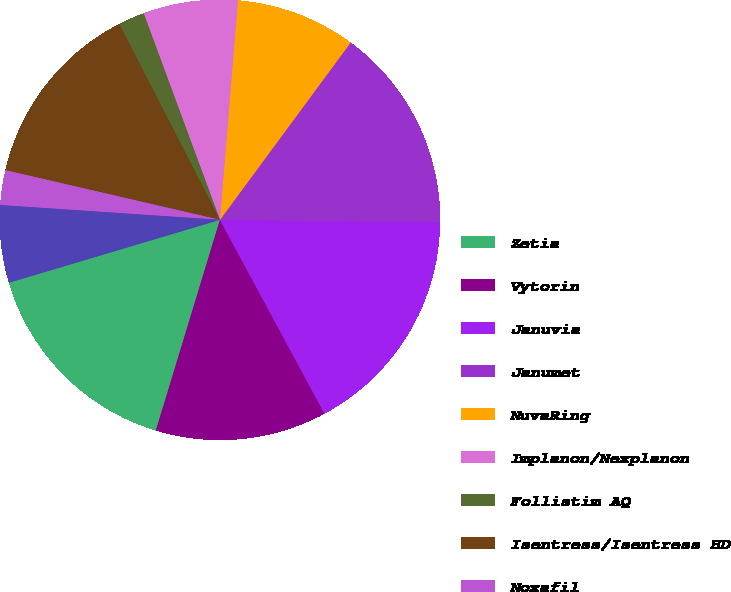Convert chart to OTSL. <chart><loc_0><loc_0><loc_500><loc_500><pie_chart><fcel>Zetia<fcel>Vytorin<fcel>Januvia<fcel>Janumet<fcel>NuvaRing<fcel>Implanon/Nexplanon<fcel>Follistim AQ<fcel>Isentress/Isentress HD<fcel>Noxafil<fcel>Invanz<nl><fcel>15.69%<fcel>12.57%<fcel>16.95%<fcel>15.07%<fcel>8.81%<fcel>6.93%<fcel>1.93%<fcel>13.82%<fcel>2.55%<fcel>5.68%<nl></chart> 